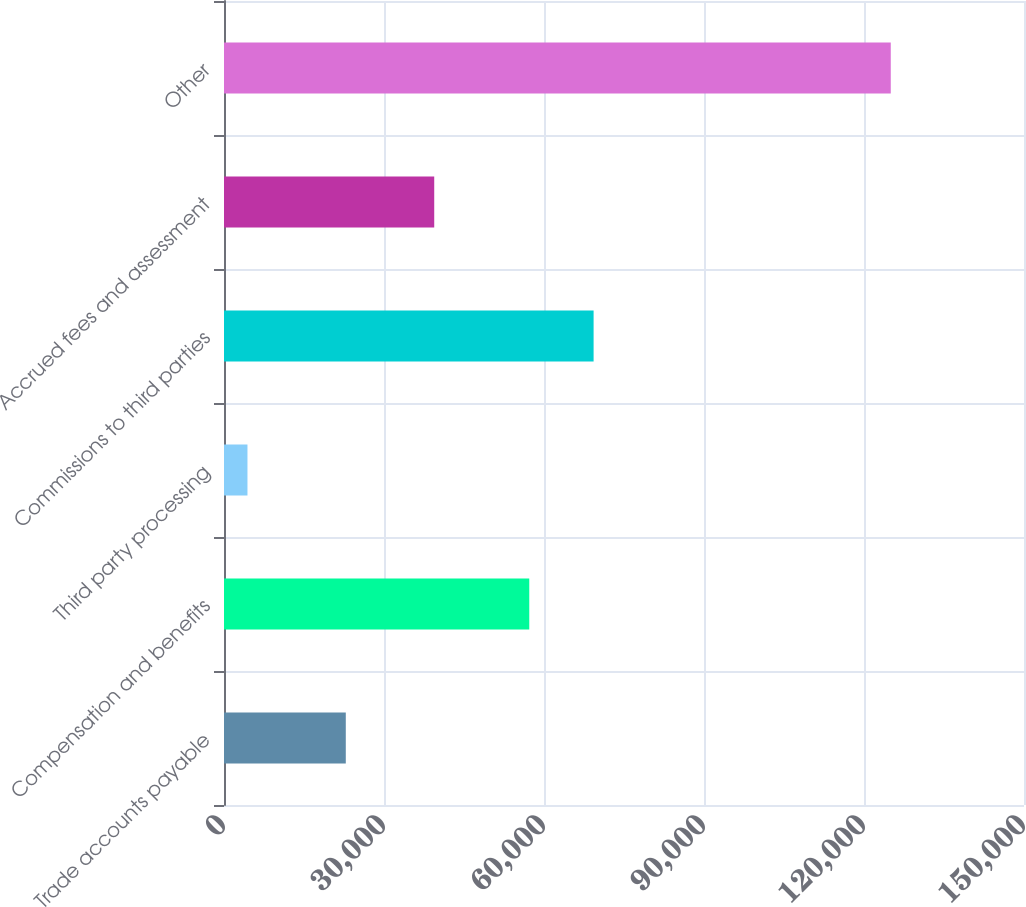Convert chart to OTSL. <chart><loc_0><loc_0><loc_500><loc_500><bar_chart><fcel>Trade accounts payable<fcel>Compensation and benefits<fcel>Third party processing<fcel>Commissions to third parties<fcel>Accrued fees and assessment<fcel>Other<nl><fcel>22836<fcel>57238<fcel>4399<fcel>69300.1<fcel>39417<fcel>125020<nl></chart> 